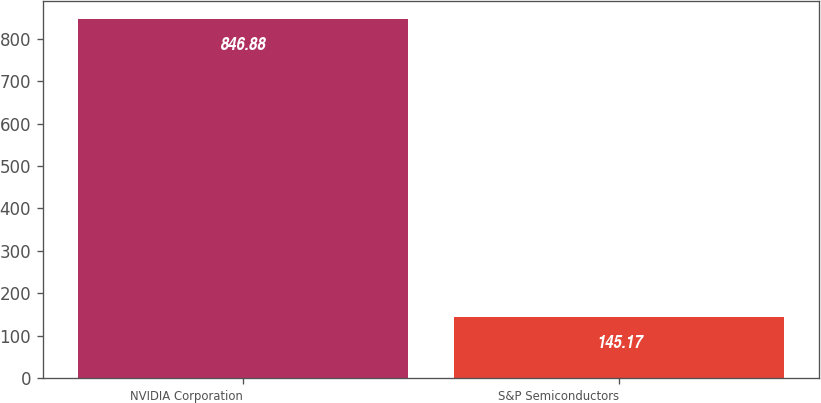Convert chart to OTSL. <chart><loc_0><loc_0><loc_500><loc_500><bar_chart><fcel>NVIDIA Corporation<fcel>S&P Semiconductors<nl><fcel>846.88<fcel>145.17<nl></chart> 